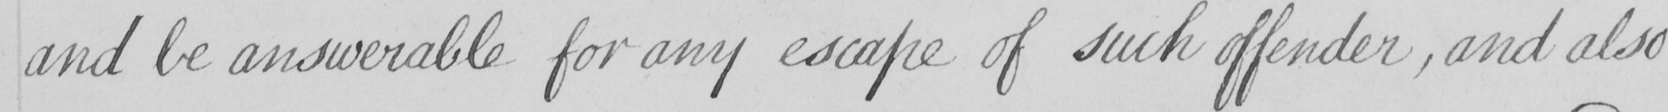Can you read and transcribe this handwriting? and be answerable for any escape of such offender , and also 